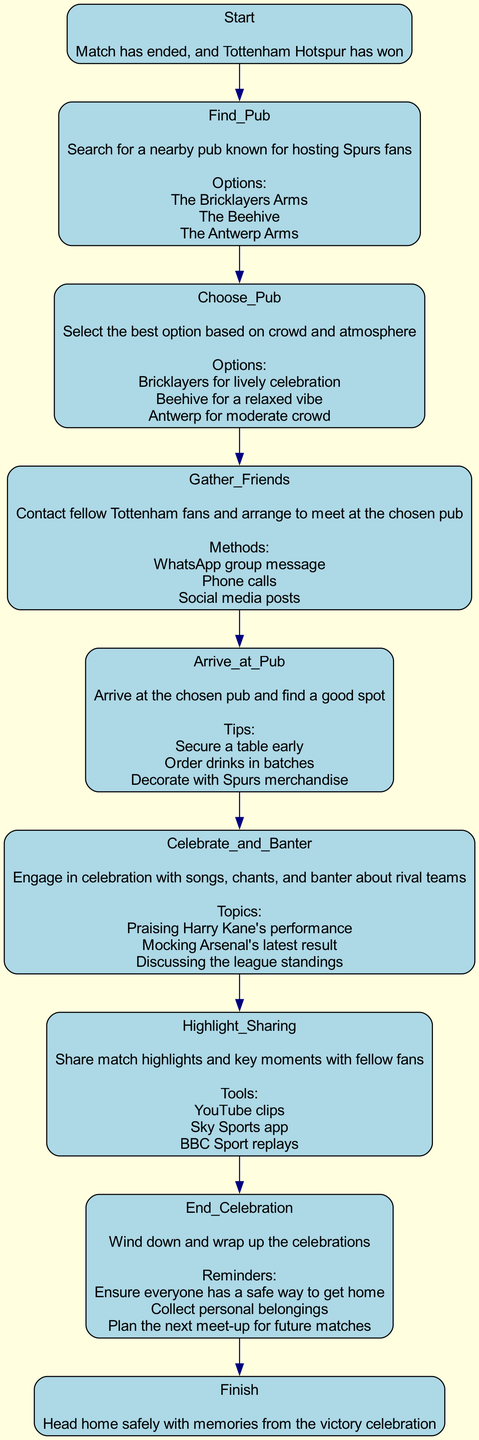What is the starting point of the flowchart? The flowchart begins at the node labeled "Start," which indicates that the match has ended and Tottenham Hotspur has won.
Answer: Start How many pubs are listed as known options? In the "Find_Pub" node, three pubs are mentioned as known options for Spurs fans. This can be counted from the options provided.
Answer: 3 What should you do after "Choose_Pub"? The next step after "Choose_Pub" is "Gather_Friends" which involves contacting fellow Tottenham fans to meet at the selected pub.
Answer: Gather_Friends Which pub option is suggested for a lively celebration? The "Choose_Pub" node includes an option for the Bricklayers Arms, which is indicated as the place for a lively celebration.
Answer: Bricklayers for lively celebration What methods can be used to gather friends at the pub? The "Gather_Friends" node lists three methods: WhatsApp group message, phone calls, and social media posts, which can be utilized to communicate with fellow fans.
Answer: WhatsApp group message, phone calls, social media posts What happens right after "Highlight_Sharing"? The flowchart indicates that after "Highlight_Sharing," the next node is "End_Celebration," which involves winding down the celebrations.
Answer: End_Celebration What are some tips to follow when arriving at the pub? In the "Arrive_at_Pub" section, tips include securing a table early, ordering drinks in batches, and decorating with Spurs merchandise, which are essential to enhance the experience.
Answer: Secure a table early, order drinks in batches, decorate with Spurs merchandise How many total nodes are present in this flowchart? By counting all the components listed in the flowchart, there are a total of eight nodes from "Start" to "Finish," inclusive.
Answer: 8 What is the final step in the celebration process? The last node in the flowchart is labeled "Finish," indicating the completion of the celebration with a safe return home.
Answer: Finish 